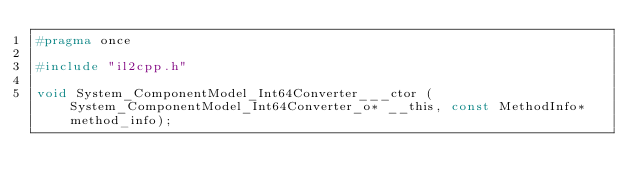<code> <loc_0><loc_0><loc_500><loc_500><_C_>#pragma once

#include "il2cpp.h"

void System_ComponentModel_Int64Converter___ctor (System_ComponentModel_Int64Converter_o* __this, const MethodInfo* method_info);
</code> 